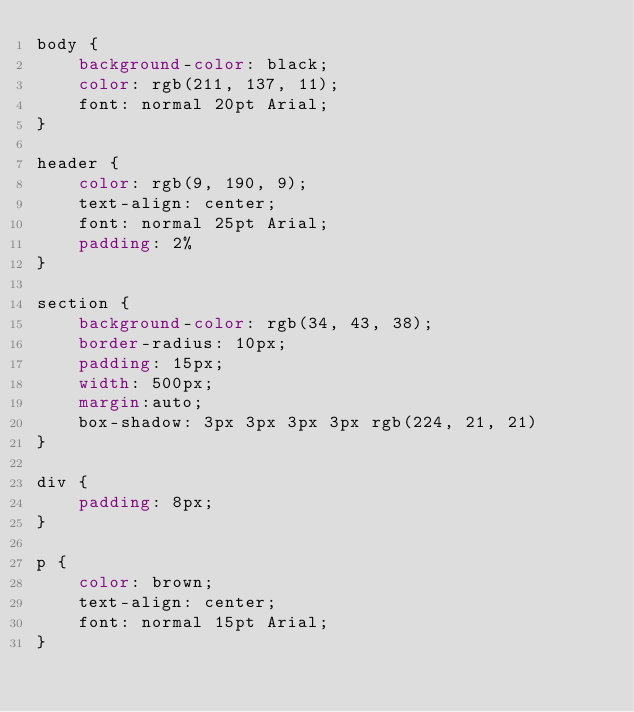<code> <loc_0><loc_0><loc_500><loc_500><_CSS_>body {
    background-color: black;
    color: rgb(211, 137, 11);
    font: normal 20pt Arial;
}

header {
    color: rgb(9, 190, 9);
    text-align: center;
    font: normal 25pt Arial;
    padding: 2%
}

section {
    background-color: rgb(34, 43, 38);
    border-radius: 10px;
    padding: 15px;
    width: 500px;
    margin:auto;
    box-shadow: 3px 3px 3px 3px rgb(224, 21, 21)
}

div {
    padding: 8px;
}

p {
    color: brown;
    text-align: center;
    font: normal 15pt Arial;
}
</code> 